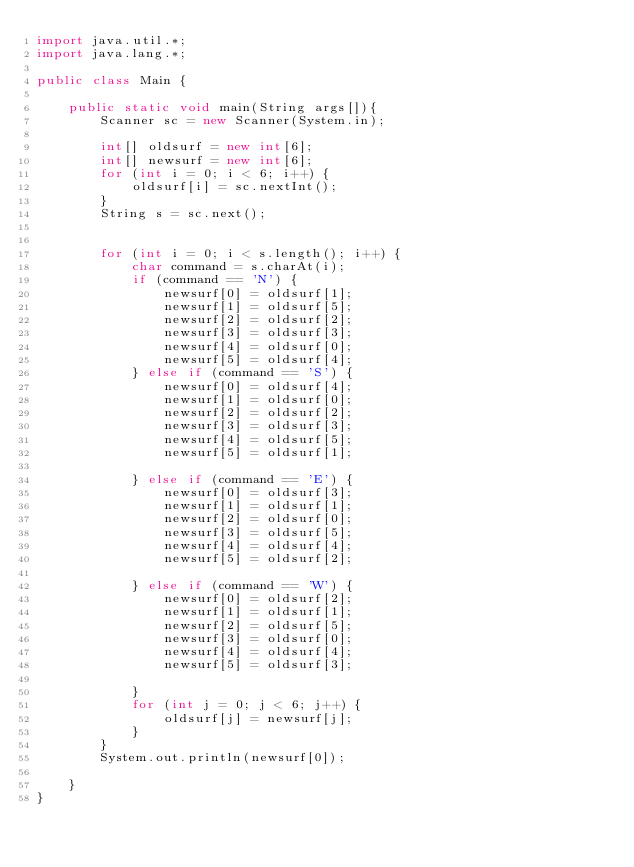<code> <loc_0><loc_0><loc_500><loc_500><_Java_>import java.util.*;
import java.lang.*;

public class Main {
    
    public static void main(String args[]){
        Scanner sc = new Scanner(System.in);
        
        int[] oldsurf = new int[6];
        int[] newsurf = new int[6];
        for (int i = 0; i < 6; i++) {
            oldsurf[i] = sc.nextInt();
        }
        String s = sc.next();

        
        for (int i = 0; i < s.length(); i++) {
            char command = s.charAt(i);
            if (command == 'N') {
                newsurf[0] = oldsurf[1];
                newsurf[1] = oldsurf[5];
                newsurf[2] = oldsurf[2];
                newsurf[3] = oldsurf[3];
                newsurf[4] = oldsurf[0];
                newsurf[5] = oldsurf[4];
            } else if (command == 'S') {
                newsurf[0] = oldsurf[4];
                newsurf[1] = oldsurf[0];
                newsurf[2] = oldsurf[2];
                newsurf[3] = oldsurf[3];
                newsurf[4] = oldsurf[5];
                newsurf[5] = oldsurf[1];
                
            } else if (command == 'E') {
                newsurf[0] = oldsurf[3];
                newsurf[1] = oldsurf[1];
                newsurf[2] = oldsurf[0];
                newsurf[3] = oldsurf[5];
                newsurf[4] = oldsurf[4];
                newsurf[5] = oldsurf[2];
                
            } else if (command == 'W') {
                newsurf[0] = oldsurf[2];
                newsurf[1] = oldsurf[1];
                newsurf[2] = oldsurf[5];
                newsurf[3] = oldsurf[0];
                newsurf[4] = oldsurf[4];
                newsurf[5] = oldsurf[3];
                
            }
            for (int j = 0; j < 6; j++) {
                oldsurf[j] = newsurf[j];
            }
        }
        System.out.println(newsurf[0]);

    }
}

</code> 